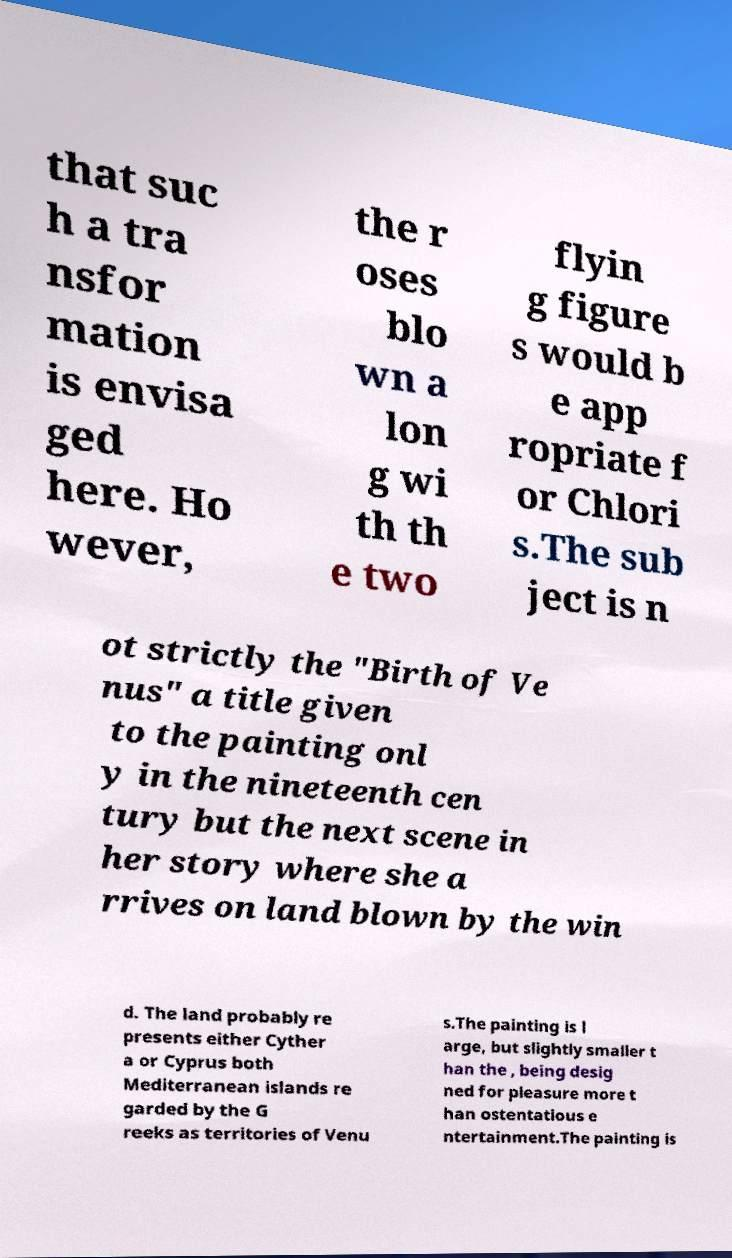Could you assist in decoding the text presented in this image and type it out clearly? that suc h a tra nsfor mation is envisa ged here. Ho wever, the r oses blo wn a lon g wi th th e two flyin g figure s would b e app ropriate f or Chlori s.The sub ject is n ot strictly the "Birth of Ve nus" a title given to the painting onl y in the nineteenth cen tury but the next scene in her story where she a rrives on land blown by the win d. The land probably re presents either Cyther a or Cyprus both Mediterranean islands re garded by the G reeks as territories of Venu s.The painting is l arge, but slightly smaller t han the , being desig ned for pleasure more t han ostentatious e ntertainment.The painting is 